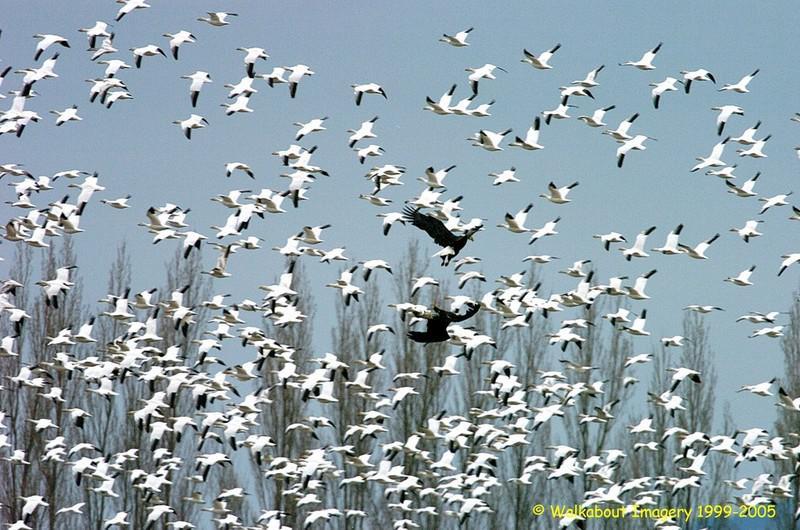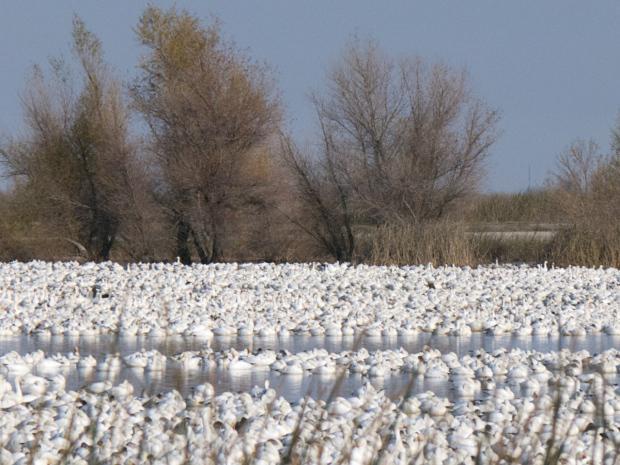The first image is the image on the left, the second image is the image on the right. For the images shown, is this caption "All of the birds are in the water in the image on the right." true? Answer yes or no. Yes. 